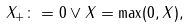<formula> <loc_0><loc_0><loc_500><loc_500>X _ { + } \colon = 0 \vee X = \max ( 0 , X ) ,</formula> 